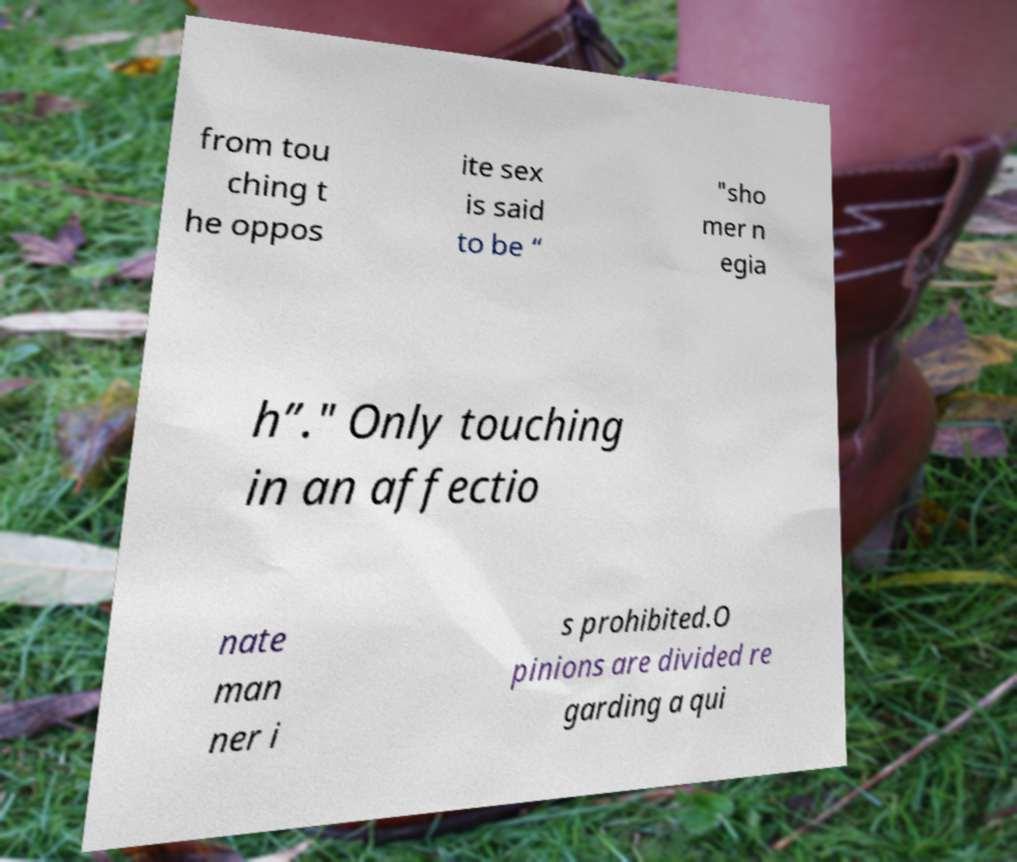What messages or text are displayed in this image? I need them in a readable, typed format. from tou ching t he oppos ite sex is said to be “ "sho mer n egia h”." Only touching in an affectio nate man ner i s prohibited.O pinions are divided re garding a qui 